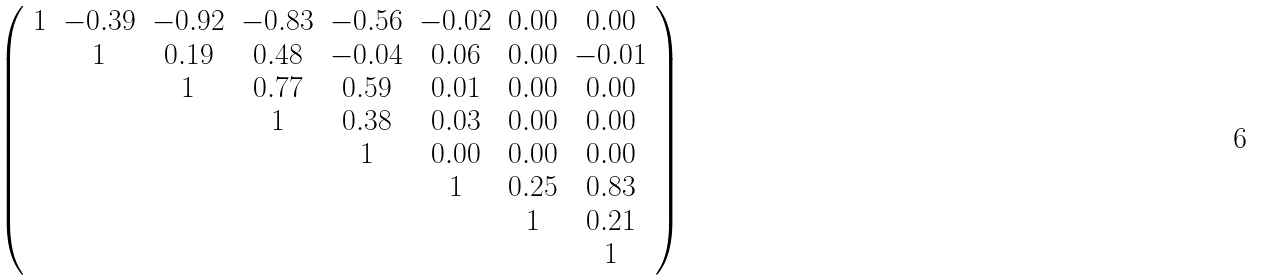<formula> <loc_0><loc_0><loc_500><loc_500>\left ( \begin{array} { c c c c c c c c } 1 & - 0 . 3 9 & - 0 . 9 2 & - 0 . 8 3 & - 0 . 5 6 & - 0 . 0 2 & 0 . 0 0 & 0 . 0 0 \\ & 1 & 0 . 1 9 & 0 . 4 8 & - 0 . 0 4 & 0 . 0 6 & 0 . 0 0 & - 0 . 0 1 \\ & & 1 & 0 . 7 7 & 0 . 5 9 & 0 . 0 1 & 0 . 0 0 & 0 . 0 0 \\ & & & 1 & 0 . 3 8 & 0 . 0 3 & 0 . 0 0 & 0 . 0 0 \\ & & & & 1 & 0 . 0 0 & 0 . 0 0 & 0 . 0 0 \\ & & & & & 1 & 0 . 2 5 & 0 . 8 3 \\ & & & & & & 1 & 0 . 2 1 \\ & & & & & & & 1 \end{array} \right )</formula> 